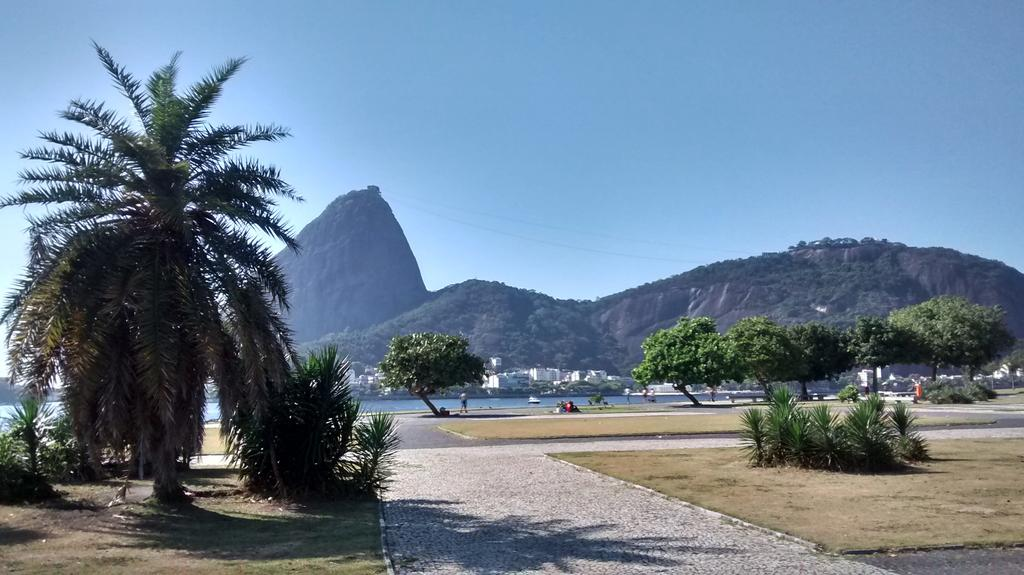What type of vegetation can be seen in the image? There are trees in the image. What is the color of the trees? The trees are green. What can be seen in the background of the image? There are mountains in the background of the image. What is visible above the trees and mountains? The sky is visible in the image. What is the color of the sky? The sky is blue. How many geese are smashing into the trees in the image? There are no geese present in the image, and therefore no such activity can be observed. 